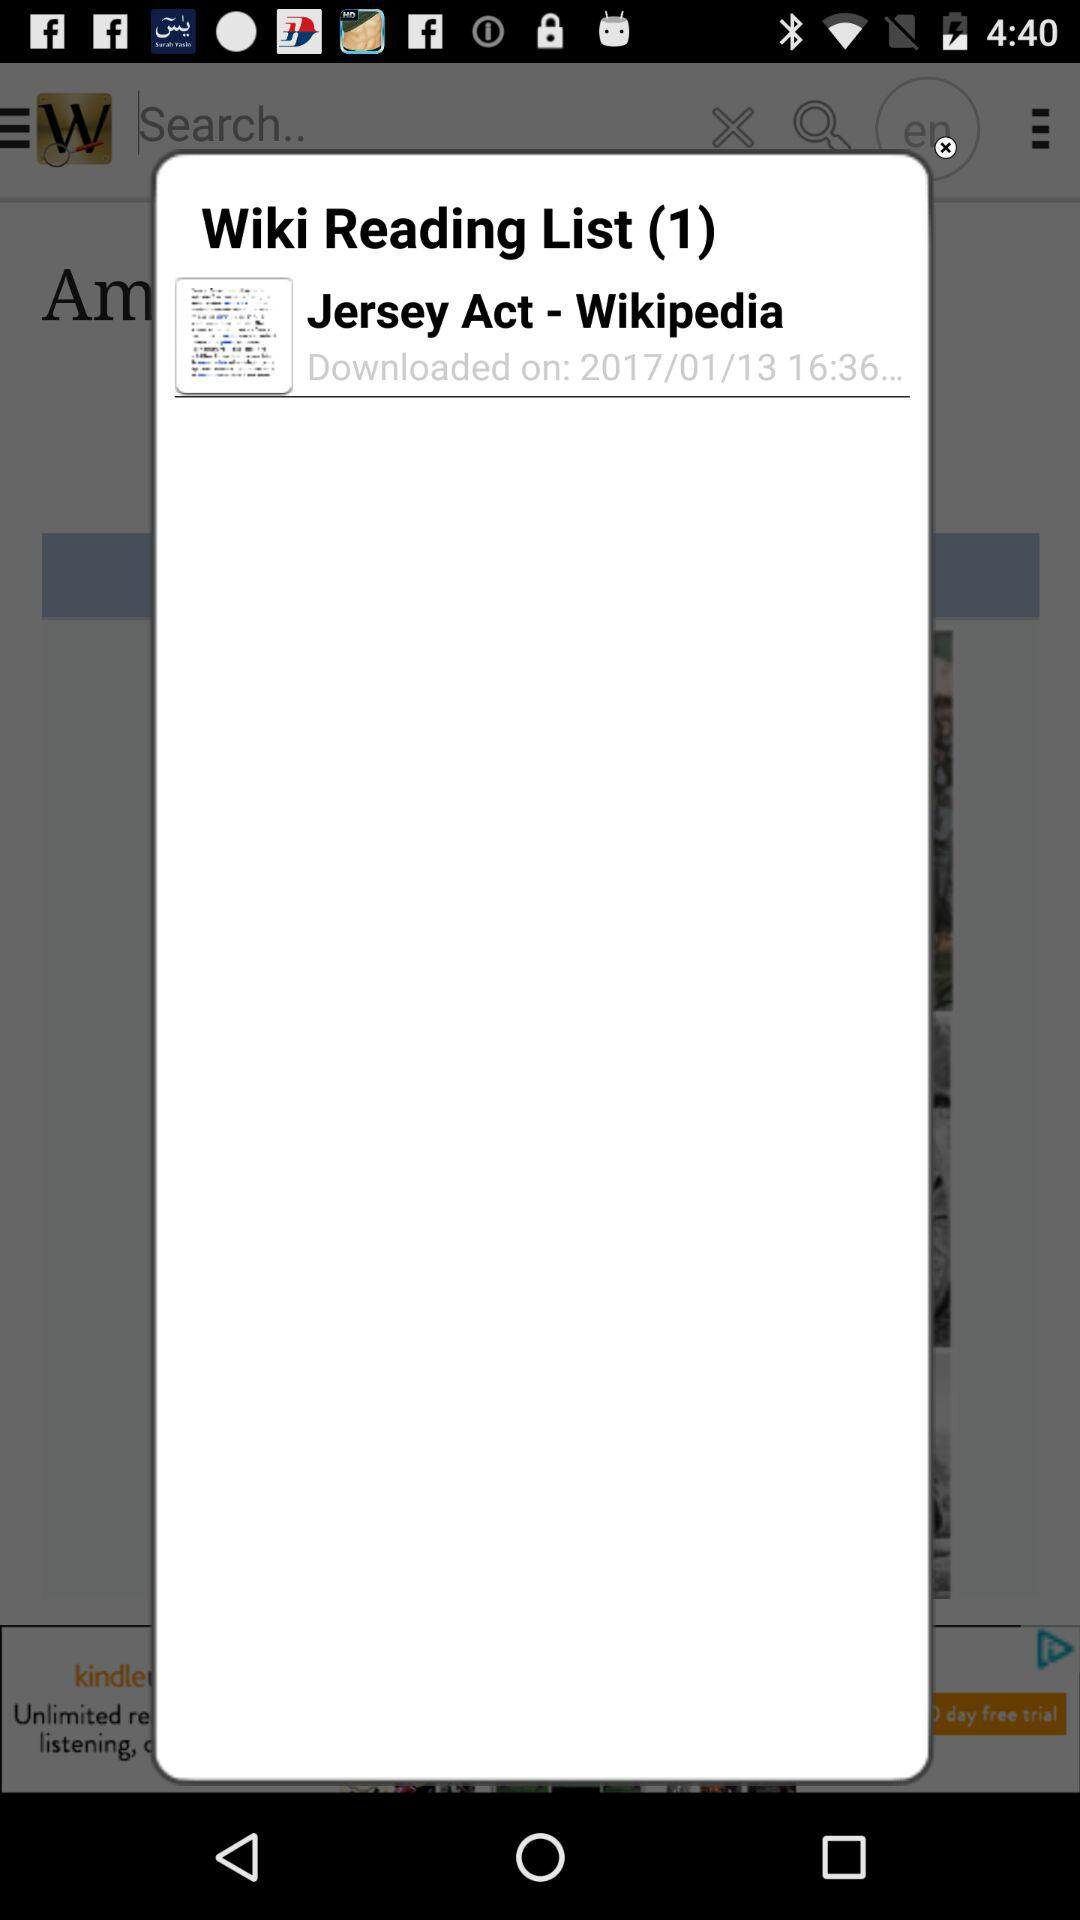What is the list number? The list number is 1. 